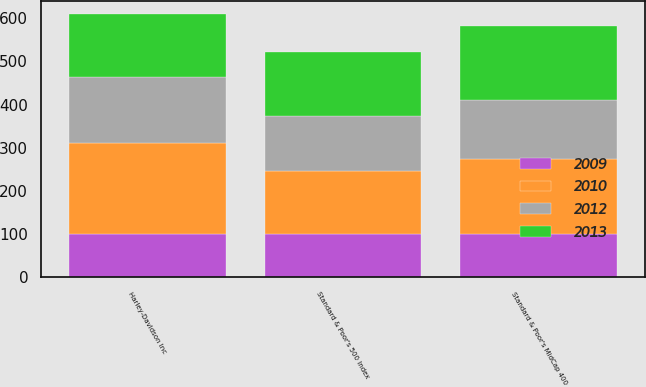Convert chart. <chart><loc_0><loc_0><loc_500><loc_500><stacked_bar_chart><ecel><fcel>Harley-Davidson Inc<fcel>Standard & Poor's MidCap 400<fcel>Standard & Poor's 500 Index<nl><fcel>2009<fcel>100<fcel>100<fcel>100<nl><fcel>2012<fcel>152<fcel>137<fcel>127<nl><fcel>2010<fcel>212<fcel>174<fcel>146<nl><fcel>2013<fcel>146<fcel>171<fcel>149<nl></chart> 